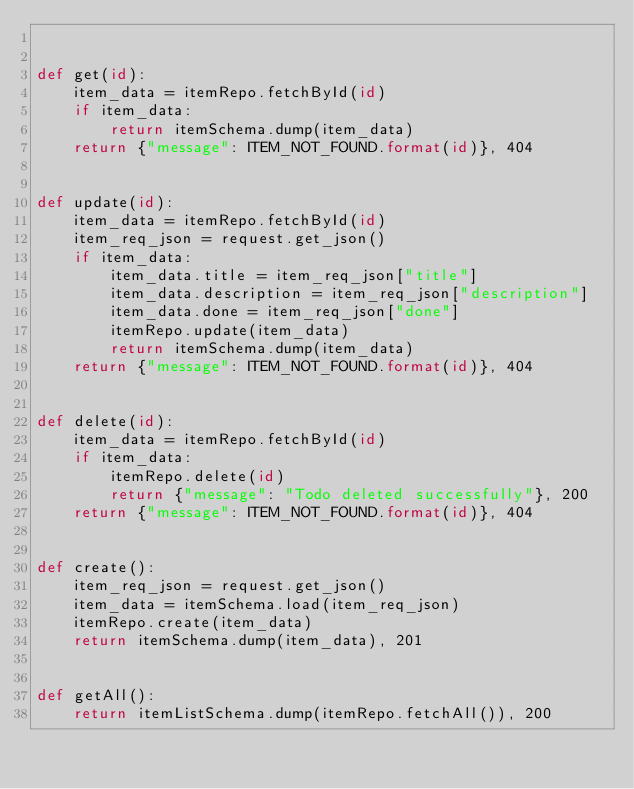<code> <loc_0><loc_0><loc_500><loc_500><_Python_>

def get(id):
    item_data = itemRepo.fetchById(id)
    if item_data:
        return itemSchema.dump(item_data)
    return {"message": ITEM_NOT_FOUND.format(id)}, 404


def update(id):
    item_data = itemRepo.fetchById(id)
    item_req_json = request.get_json()
    if item_data:
        item_data.title = item_req_json["title"]
        item_data.description = item_req_json["description"]
        item_data.done = item_req_json["done"]
        itemRepo.update(item_data)
        return itemSchema.dump(item_data)
    return {"message": ITEM_NOT_FOUND.format(id)}, 404


def delete(id):
    item_data = itemRepo.fetchById(id)
    if item_data:
        itemRepo.delete(id)
        return {"message": "Todo deleted successfully"}, 200
    return {"message": ITEM_NOT_FOUND.format(id)}, 404


def create():
    item_req_json = request.get_json()
    item_data = itemSchema.load(item_req_json)
    itemRepo.create(item_data)
    return itemSchema.dump(item_data), 201


def getAll():
    return itemListSchema.dump(itemRepo.fetchAll()), 200
</code> 